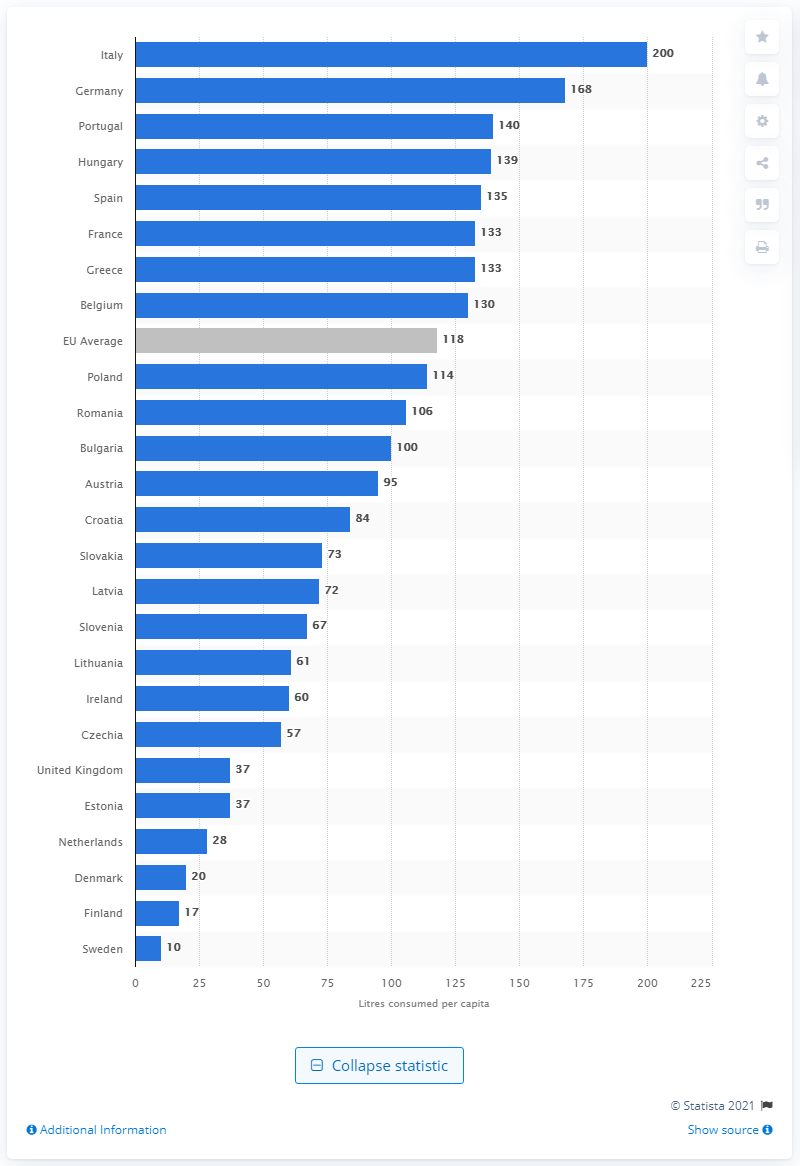Specify some key components in this picture. In Germany in 2019, the average person consumed 168 liters of bottled water. According to data from 2019, Italy was the country with the highest consumption of bottled water. 